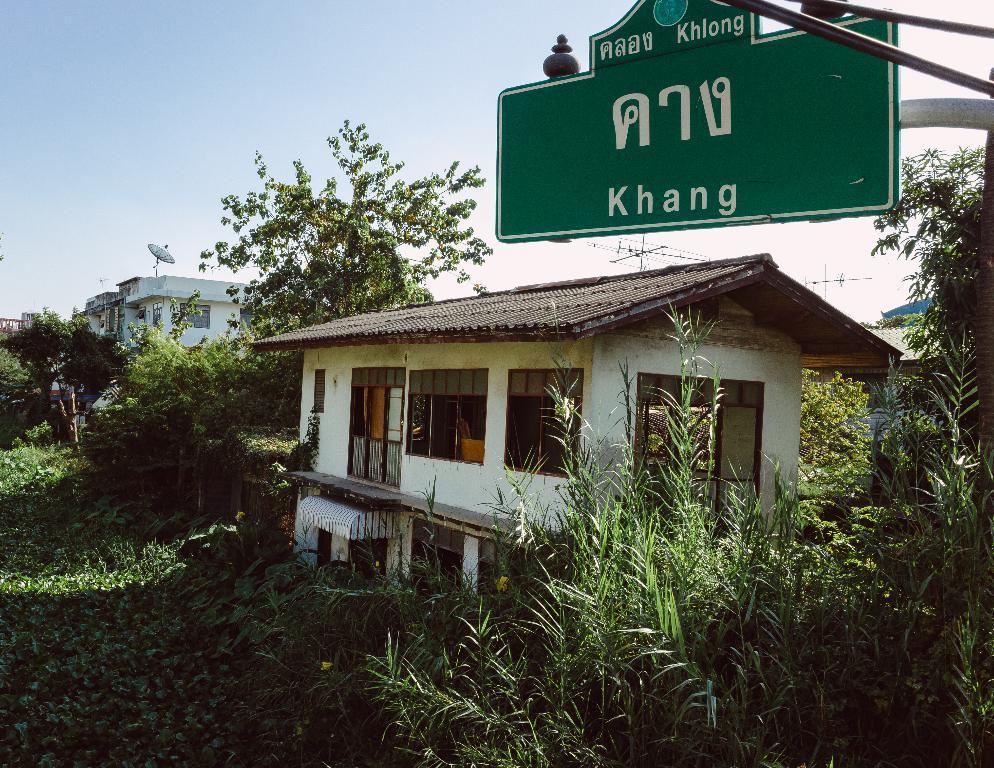In one or two sentences, can you explain what this image depicts? As we can see in the image there are buildings, sign pole, trees, grass, current poles and on the top there is sky. 